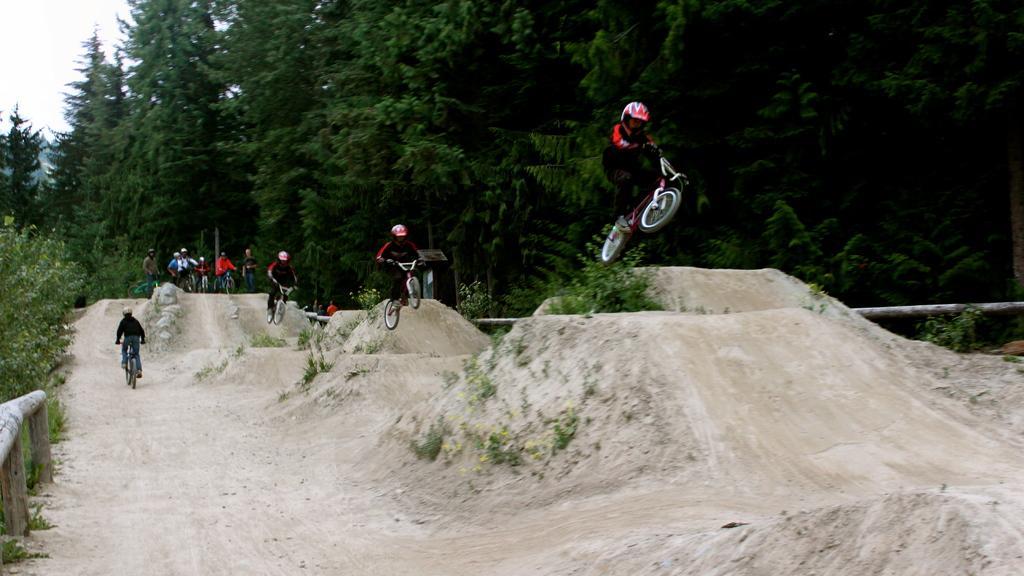Please provide a concise description of this image. In this picture I can see few people are riding bicycles and I can see trees, plants and a cloudy sky. 